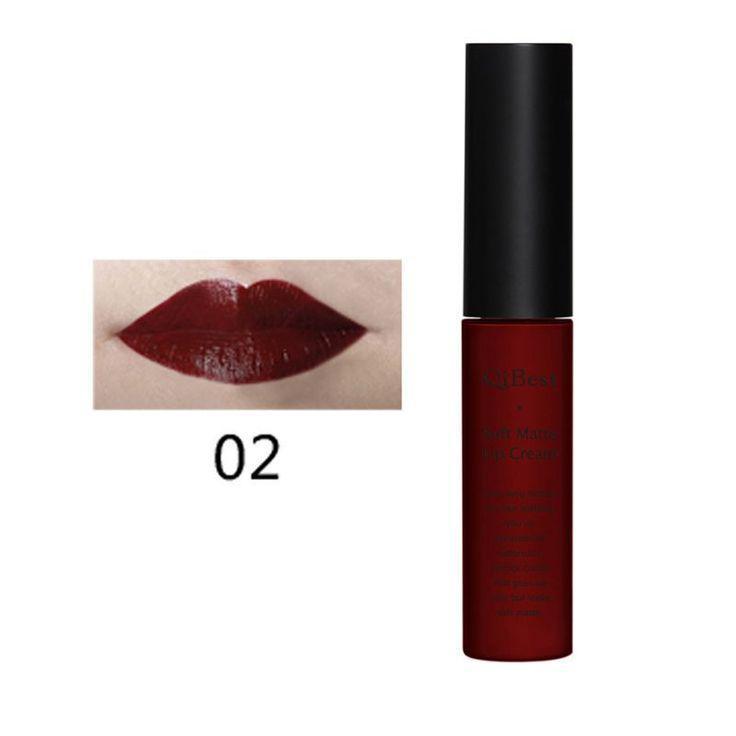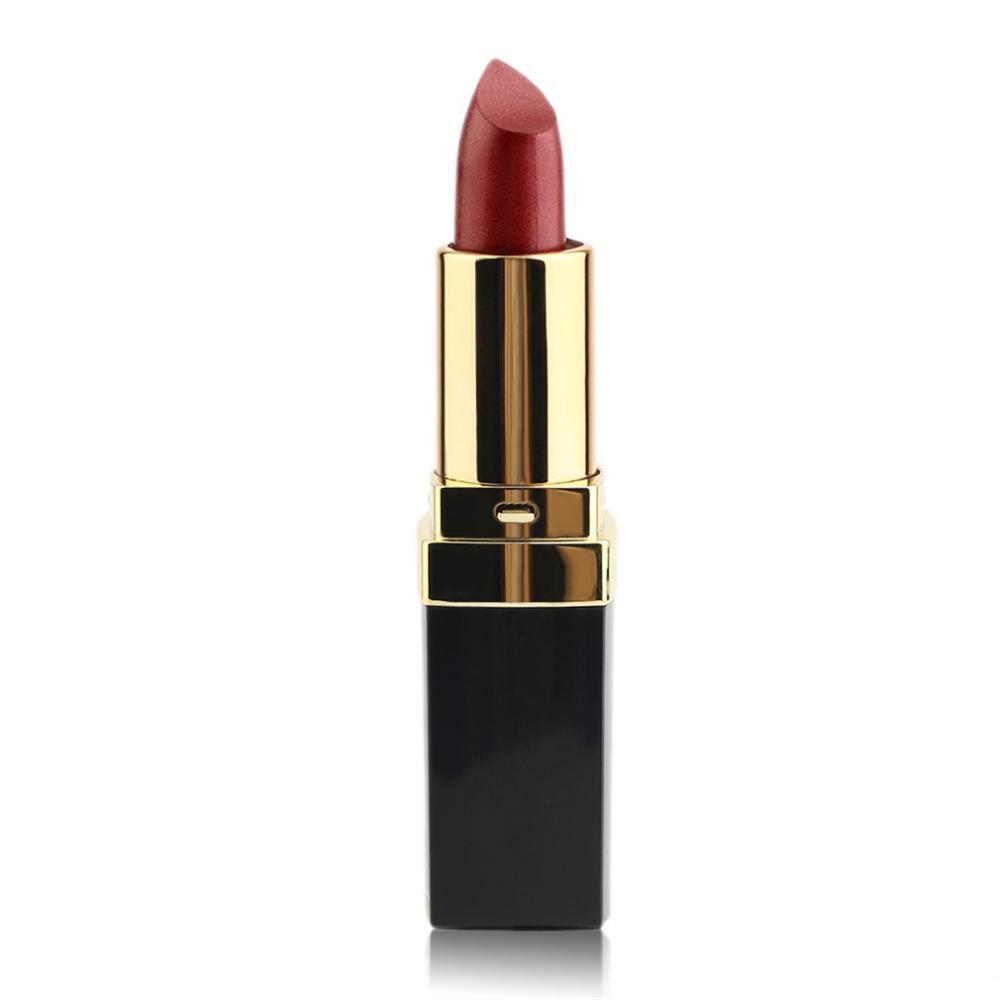The first image is the image on the left, the second image is the image on the right. Assess this claim about the two images: "Exactly two lipsticks are shown, one of them capped, but with a lip photo display, while the other is open with the lipstick extended.". Correct or not? Answer yes or no. Yes. The first image is the image on the left, the second image is the image on the right. Assess this claim about the two images: "An image shows one pair of painted lips to the right of a single lip makeup product.". Correct or not? Answer yes or no. No. 